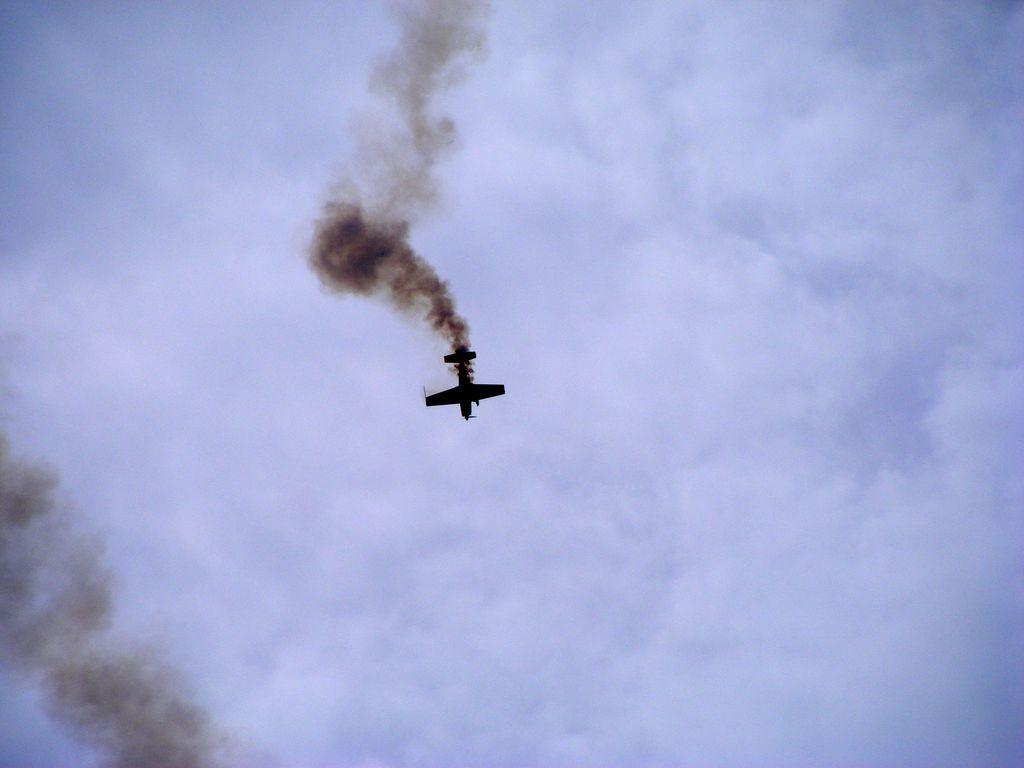What is the main subject of the image? The main subject of the image is an aircraft. What is the aircraft doing in the image? The aircraft is flying in the sky. What else can be observed about the aircraft in the image? The aircraft is releasing smoke. Can you recall any memories of the fireman swimming in the image? There is no fireman or swimming activity present in the image; it features an aircraft flying in the sky and releasing smoke. 